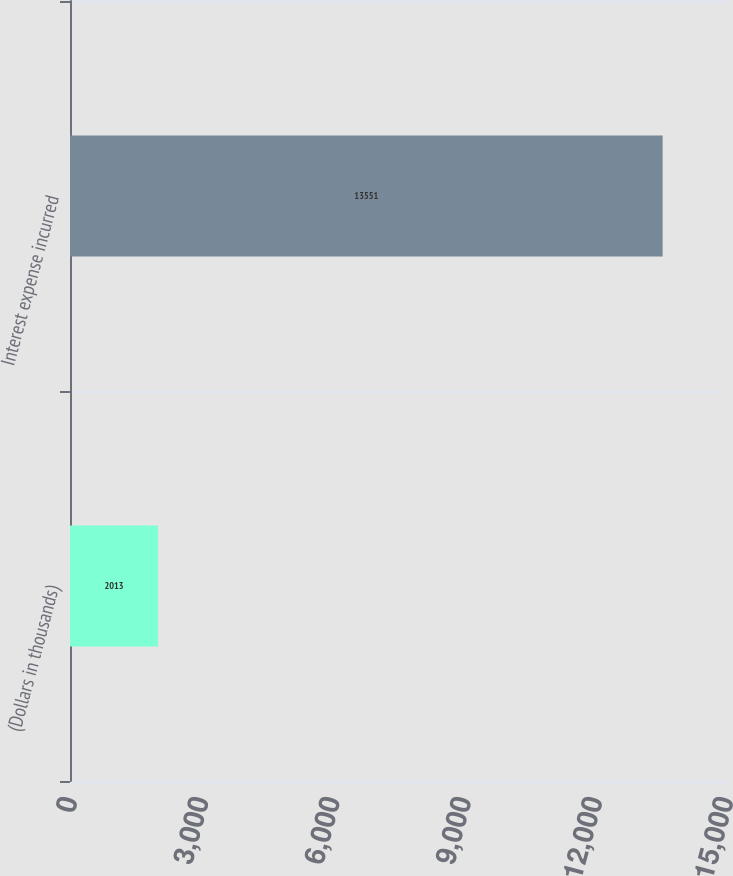<chart> <loc_0><loc_0><loc_500><loc_500><bar_chart><fcel>(Dollars in thousands)<fcel>Interest expense incurred<nl><fcel>2013<fcel>13551<nl></chart> 